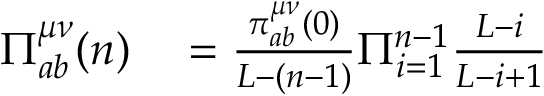Convert formula to latex. <formula><loc_0><loc_0><loc_500><loc_500>\begin{array} { r l } { \Pi _ { a b } ^ { \mu \nu } ( n ) } & = \frac { \pi _ { a b } ^ { \mu \nu } ( 0 ) } { L - ( n - 1 ) } \Pi _ { i = 1 } ^ { n - 1 } \frac { L - i } { L - i + 1 } } \end{array}</formula> 